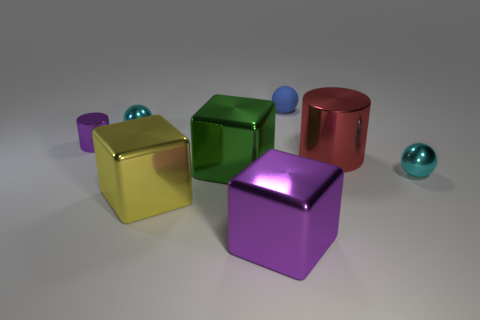There is a small object that is behind the large green cube and right of the purple metallic block; what material is it made of?
Make the answer very short. Rubber. Is the number of cyan metallic spheres that are behind the red thing less than the number of large shiny objects on the right side of the purple shiny cylinder?
Provide a short and direct response. Yes. How many other things are the same size as the red thing?
Offer a terse response. 3. What is the shape of the cyan object that is to the left of the tiny blue ball behind the cyan metal sphere in front of the large red metal object?
Make the answer very short. Sphere. What number of purple objects are either spheres or small cylinders?
Your response must be concise. 1. What number of tiny balls are on the left side of the cyan object on the right side of the small rubber object?
Give a very brief answer. 2. Is there any other thing that is the same color as the small metallic cylinder?
Provide a succinct answer. Yes. What is the shape of the green thing that is made of the same material as the big purple thing?
Your answer should be very brief. Cube. Do the cylinder on the left side of the blue rubber ball and the cyan sphere that is to the left of the large green cube have the same material?
Give a very brief answer. Yes. How many things are big gray cubes or things on the left side of the blue matte thing?
Ensure brevity in your answer.  5. 